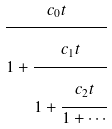<formula> <loc_0><loc_0><loc_500><loc_500>\cfrac { c _ { 0 } t } { 1 + \cfrac { c _ { 1 } t } { 1 + \cfrac { c _ { 2 } t } { 1 + \cdots } } }</formula> 